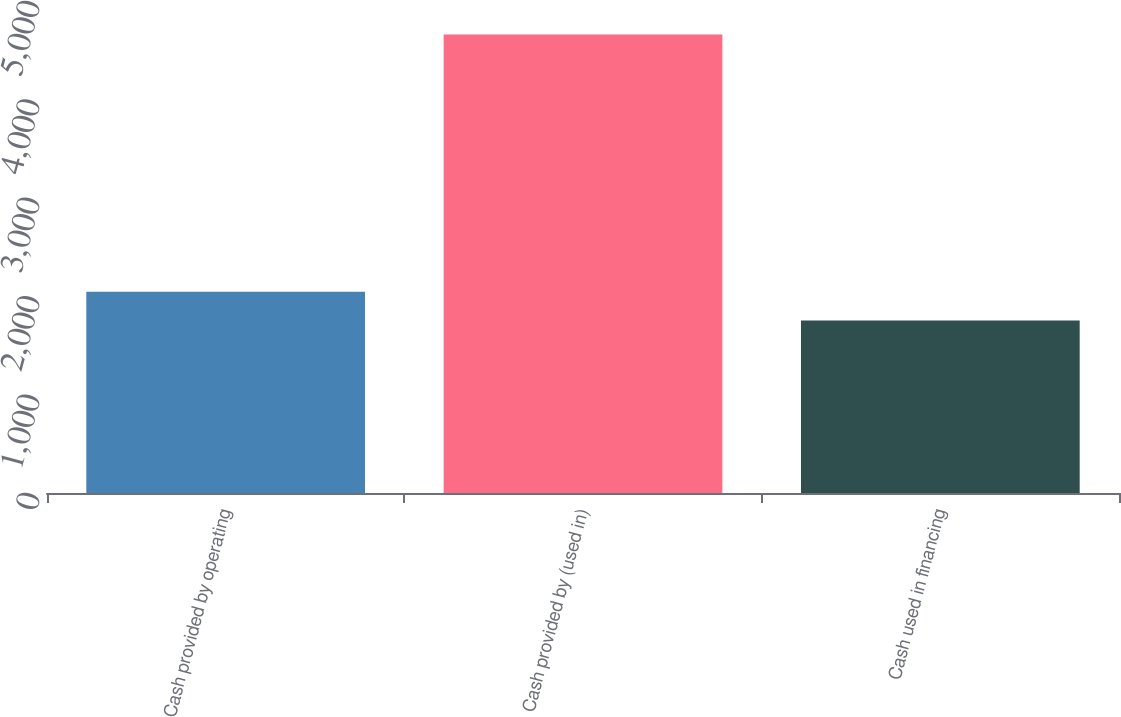<chart> <loc_0><loc_0><loc_500><loc_500><bar_chart><fcel>Cash provided by operating<fcel>Cash provided by (used in)<fcel>Cash used in financing<nl><fcel>2044.6<fcel>4660<fcel>1754<nl></chart> 